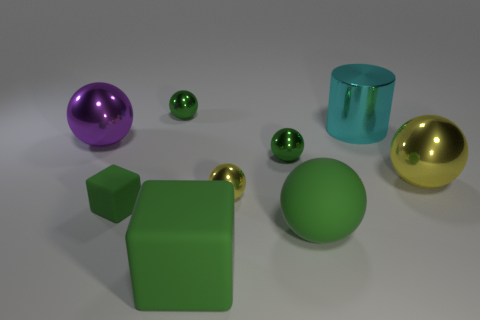Is there a cylinder that has the same material as the large purple ball?
Keep it short and to the point. Yes. There is a yellow sphere that is the same size as the purple object; what material is it?
Make the answer very short. Metal. Are there fewer big yellow spheres behind the large yellow ball than spheres in front of the tiny green rubber object?
Offer a very short reply. Yes. The metal object that is to the left of the large block and in front of the large cyan metal object has what shape?
Keep it short and to the point. Sphere. What number of small things have the same shape as the big purple shiny object?
Your answer should be compact. 3. What size is the yellow object that is the same material as the big yellow sphere?
Give a very brief answer. Small. Is the number of big green rubber balls greater than the number of metallic blocks?
Your response must be concise. Yes. There is a large matte object that is on the right side of the tiny yellow metallic thing; what color is it?
Your answer should be very brief. Green. How big is the metal object that is left of the big green cube and on the right side of the purple shiny ball?
Offer a terse response. Small. How many green cubes have the same size as the shiny cylinder?
Ensure brevity in your answer.  1. 